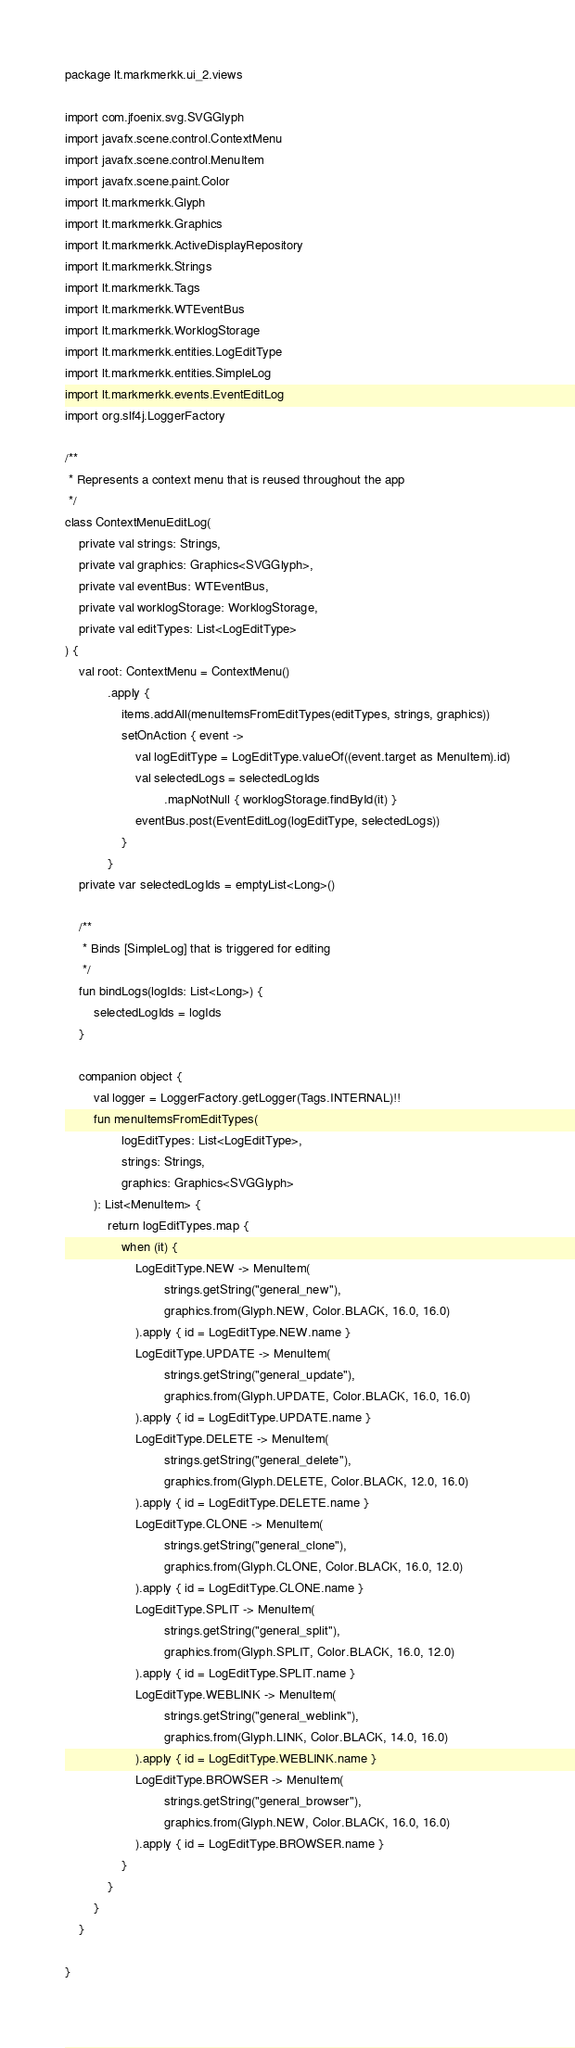Convert code to text. <code><loc_0><loc_0><loc_500><loc_500><_Kotlin_>package lt.markmerkk.ui_2.views

import com.jfoenix.svg.SVGGlyph
import javafx.scene.control.ContextMenu
import javafx.scene.control.MenuItem
import javafx.scene.paint.Color
import lt.markmerkk.Glyph
import lt.markmerkk.Graphics
import lt.markmerkk.ActiveDisplayRepository
import lt.markmerkk.Strings
import lt.markmerkk.Tags
import lt.markmerkk.WTEventBus
import lt.markmerkk.WorklogStorage
import lt.markmerkk.entities.LogEditType
import lt.markmerkk.entities.SimpleLog
import lt.markmerkk.events.EventEditLog
import org.slf4j.LoggerFactory

/**
 * Represents a context menu that is reused throughout the app
 */
class ContextMenuEditLog(
    private val strings: Strings,
    private val graphics: Graphics<SVGGlyph>,
    private val eventBus: WTEventBus,
    private val worklogStorage: WorklogStorage,
    private val editTypes: List<LogEditType>
) {
    val root: ContextMenu = ContextMenu()
            .apply {
                items.addAll(menuItemsFromEditTypes(editTypes, strings, graphics))
                setOnAction { event ->
                    val logEditType = LogEditType.valueOf((event.target as MenuItem).id)
                    val selectedLogs = selectedLogIds
                            .mapNotNull { worklogStorage.findById(it) }
                    eventBus.post(EventEditLog(logEditType, selectedLogs))
                }
            } 
    private var selectedLogIds = emptyList<Long>()

    /**
     * Binds [SimpleLog] that is triggered for editing
     */
    fun bindLogs(logIds: List<Long>) {
        selectedLogIds = logIds
    }

    companion object {
        val logger = LoggerFactory.getLogger(Tags.INTERNAL)!!
        fun menuItemsFromEditTypes(
                logEditTypes: List<LogEditType>,
                strings: Strings,
                graphics: Graphics<SVGGlyph>
        ): List<MenuItem> {
            return logEditTypes.map {
                when (it) {
                    LogEditType.NEW -> MenuItem(
                            strings.getString("general_new"),
                            graphics.from(Glyph.NEW, Color.BLACK, 16.0, 16.0)
                    ).apply { id = LogEditType.NEW.name }
                    LogEditType.UPDATE -> MenuItem(
                            strings.getString("general_update"),
                            graphics.from(Glyph.UPDATE, Color.BLACK, 16.0, 16.0)
                    ).apply { id = LogEditType.UPDATE.name }
                    LogEditType.DELETE -> MenuItem(
                            strings.getString("general_delete"),
                            graphics.from(Glyph.DELETE, Color.BLACK, 12.0, 16.0)
                    ).apply { id = LogEditType.DELETE.name }
                    LogEditType.CLONE -> MenuItem(
                            strings.getString("general_clone"),
                            graphics.from(Glyph.CLONE, Color.BLACK, 16.0, 12.0)
                    ).apply { id = LogEditType.CLONE.name }
                    LogEditType.SPLIT -> MenuItem(
                            strings.getString("general_split"),
                            graphics.from(Glyph.SPLIT, Color.BLACK, 16.0, 12.0)
                    ).apply { id = LogEditType.SPLIT.name }
                    LogEditType.WEBLINK -> MenuItem(
                            strings.getString("general_weblink"),
                            graphics.from(Glyph.LINK, Color.BLACK, 14.0, 16.0)
                    ).apply { id = LogEditType.WEBLINK.name }
                    LogEditType.BROWSER -> MenuItem(
                            strings.getString("general_browser"),
                            graphics.from(Glyph.NEW, Color.BLACK, 16.0, 16.0)
                    ).apply { id = LogEditType.BROWSER.name }
                }
            }
        }
    }

}</code> 